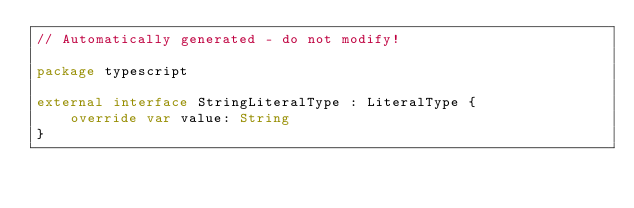<code> <loc_0><loc_0><loc_500><loc_500><_Kotlin_>// Automatically generated - do not modify!

package typescript

external interface StringLiteralType : LiteralType {
    override var value: String
}
</code> 